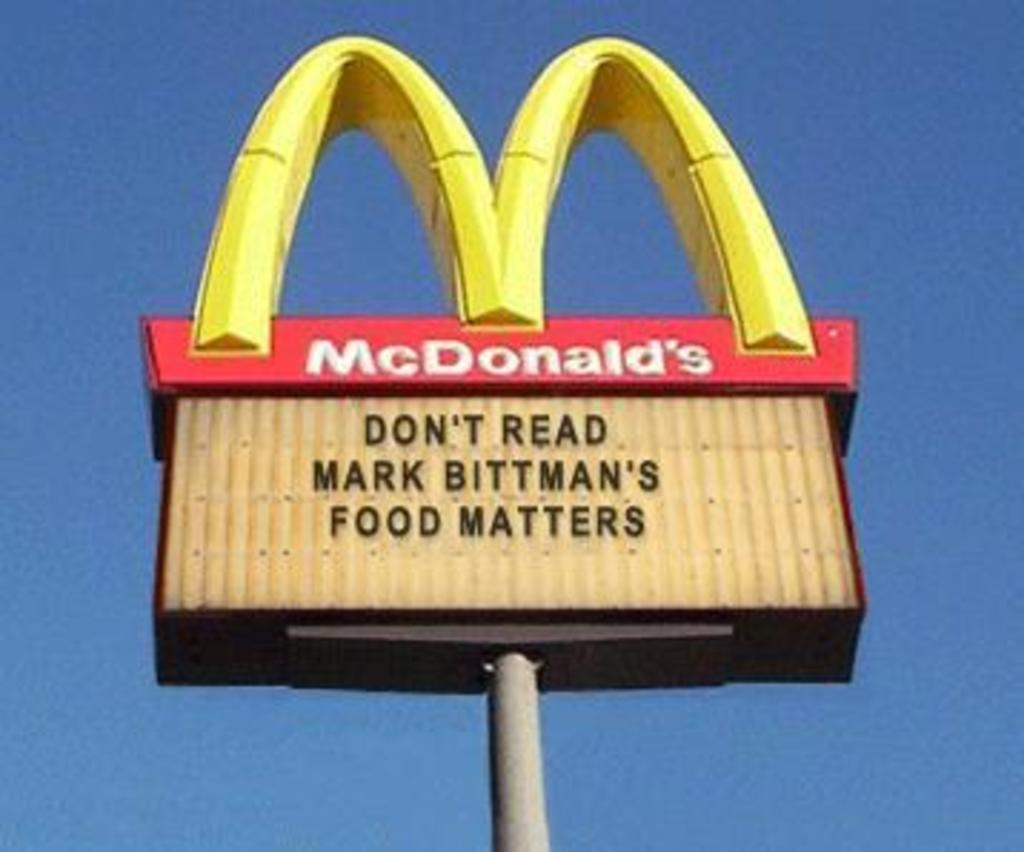<image>
Share a concise interpretation of the image provided. A McDonald's billboard features a witty quote about Mark Bittman. 